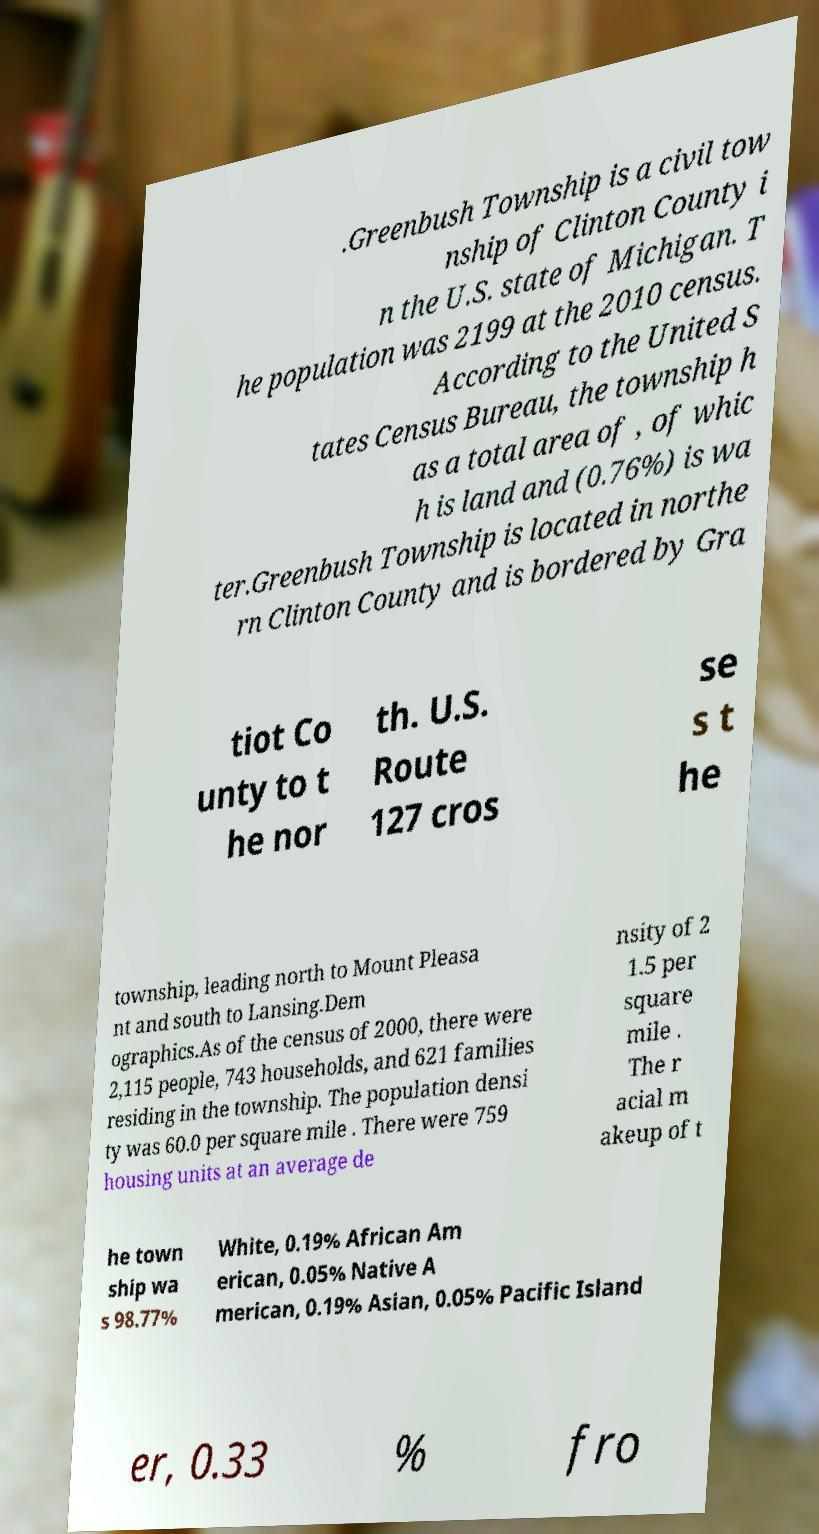Can you accurately transcribe the text from the provided image for me? .Greenbush Township is a civil tow nship of Clinton County i n the U.S. state of Michigan. T he population was 2199 at the 2010 census. According to the United S tates Census Bureau, the township h as a total area of , of whic h is land and (0.76%) is wa ter.Greenbush Township is located in northe rn Clinton County and is bordered by Gra tiot Co unty to t he nor th. U.S. Route 127 cros se s t he township, leading north to Mount Pleasa nt and south to Lansing.Dem ographics.As of the census of 2000, there were 2,115 people, 743 households, and 621 families residing in the township. The population densi ty was 60.0 per square mile . There were 759 housing units at an average de nsity of 2 1.5 per square mile . The r acial m akeup of t he town ship wa s 98.77% White, 0.19% African Am erican, 0.05% Native A merican, 0.19% Asian, 0.05% Pacific Island er, 0.33 % fro 